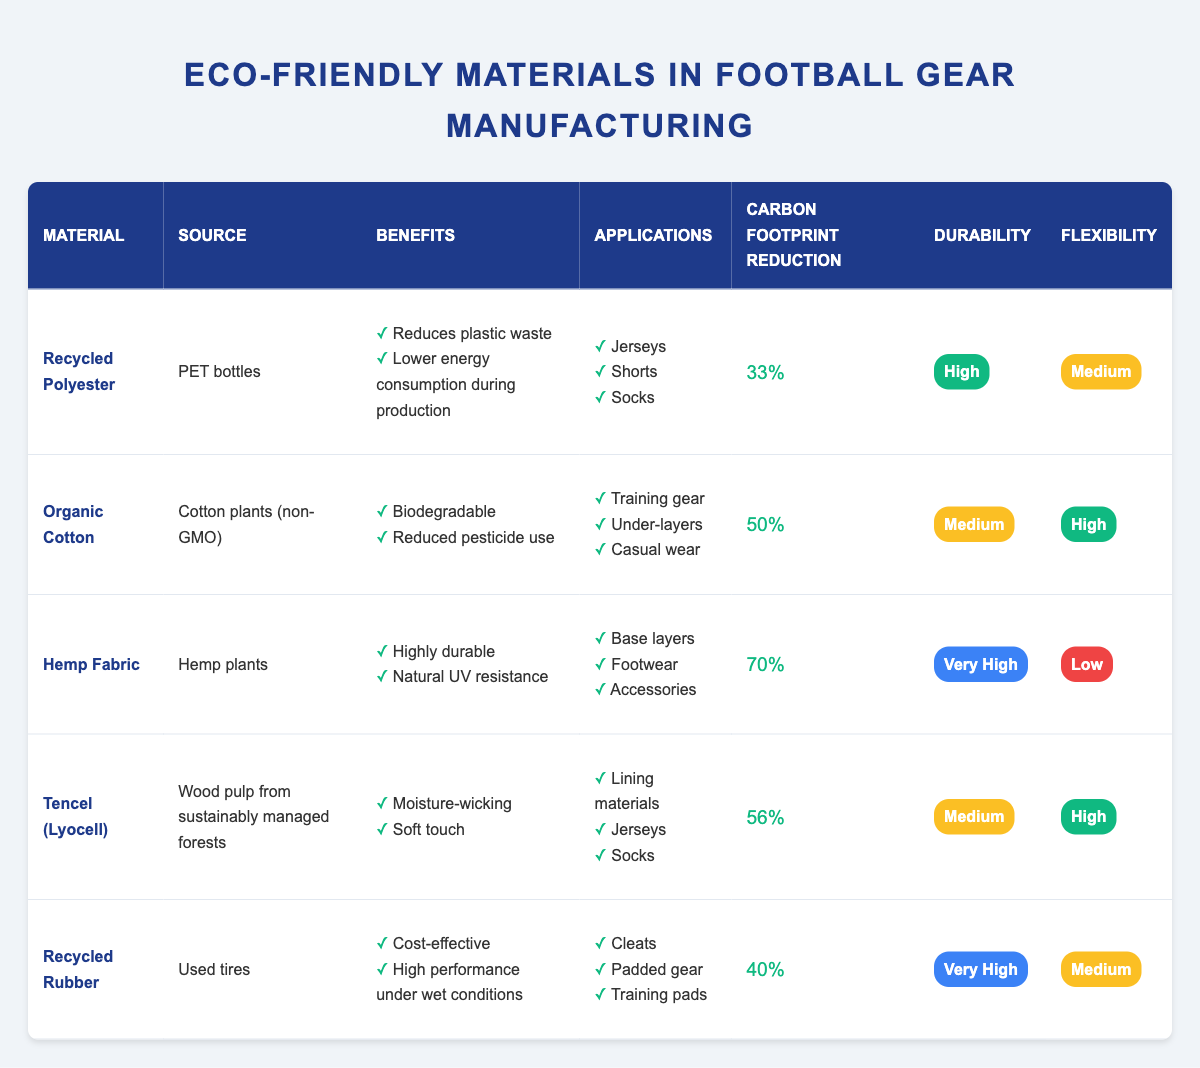What is the carbon footprint reduction percentage of Hemp Fabric? The table lists the carbon footprint reduction for Hemp Fabric as 70%.
Answer: 70% Which material has the highest durability rating? By comparing the durability ratings, Hemp Fabric has a "Very High" durability rating, which is the highest among the materials listed.
Answer: Hemp Fabric What are the applications for Organic Cotton? The table shows that Organic Cotton can be used for Training gear, Under-layers, and Casual wear.
Answer: Training gear, Under-layers, Casual wear Is Recycled Polyester biodegradable? The benefits for Recycled Polyester do not mention biodegradability, whereas Organic Cotton specifically states it is biodegradable. Thus, the answer is no.
Answer: No What is the average carbon footprint reduction percentage of all materials? First, we sum the carbon footprint reductions: 33% + 50% + 70% + 56% + 40% = 249%. Then, we divide by the number of materials (5) to get the average: 249% / 5 = 49.8%.
Answer: 49.8% Which materials can be used for jerseys? According to the applications listed in the table, Recycled Polyester, Tencel (Lyocell), and Organic Cotton can all be used for jerseys.
Answer: Recycled Polyester, Tencel (Lyocell), Organic Cotton What is the durability rating of Tencel (Lyocell)? The table indicates Tencel (Lyocell) has a "Medium" durability rating.
Answer: Medium Which material has the lowest flexibility rating? By examining the flexibility ratings, Hemp Fabric is listed as having a "Low" flexibility rating, which is the lowest among all materials.
Answer: Hemp Fabric Are all materials listed in the table derived from sustainable sources? The sources for the materials indicate that Organic Cotton, Hemp Fabric, and Tencel (Lyocell) come from sustainable sources, so not all materials can be classified as sustainable, such as Recycled Rubber from used tires. Thus, the answer is no.
Answer: No How many materials have a carbon footprint reduction of at least 40%? The materials with carbon footprint reductions of 40% or more are Recycled Polyester (33%), Organic Cotton (50%), Hemp Fabric (70%), Tencel (Lyocell) (56%), and Recycled Rubber (40%), totaling five materials.
Answer: 5 